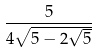<formula> <loc_0><loc_0><loc_500><loc_500>\frac { 5 } { 4 \sqrt { 5 - 2 \sqrt { 5 } } }</formula> 